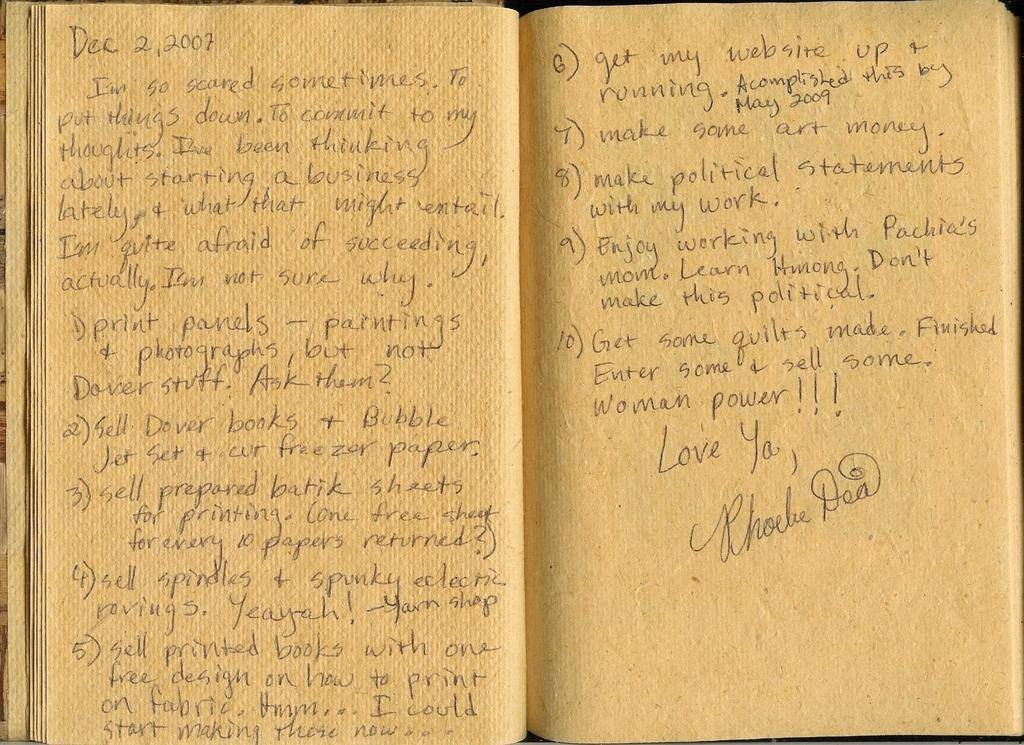<image>
Describe the image concisely. An open book with text on both pages and the date for december second 2007 on the top left side. 